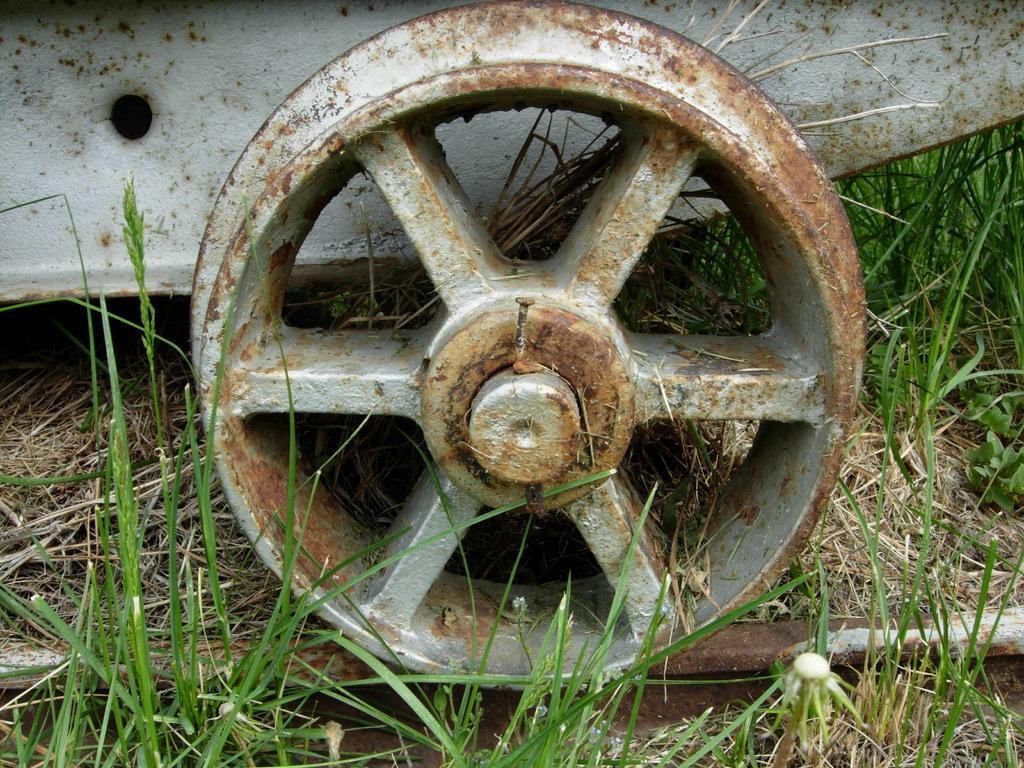Could you give a brief overview of what you see in this image? In this image there is an iron wheel on the track, which is on the grass. 